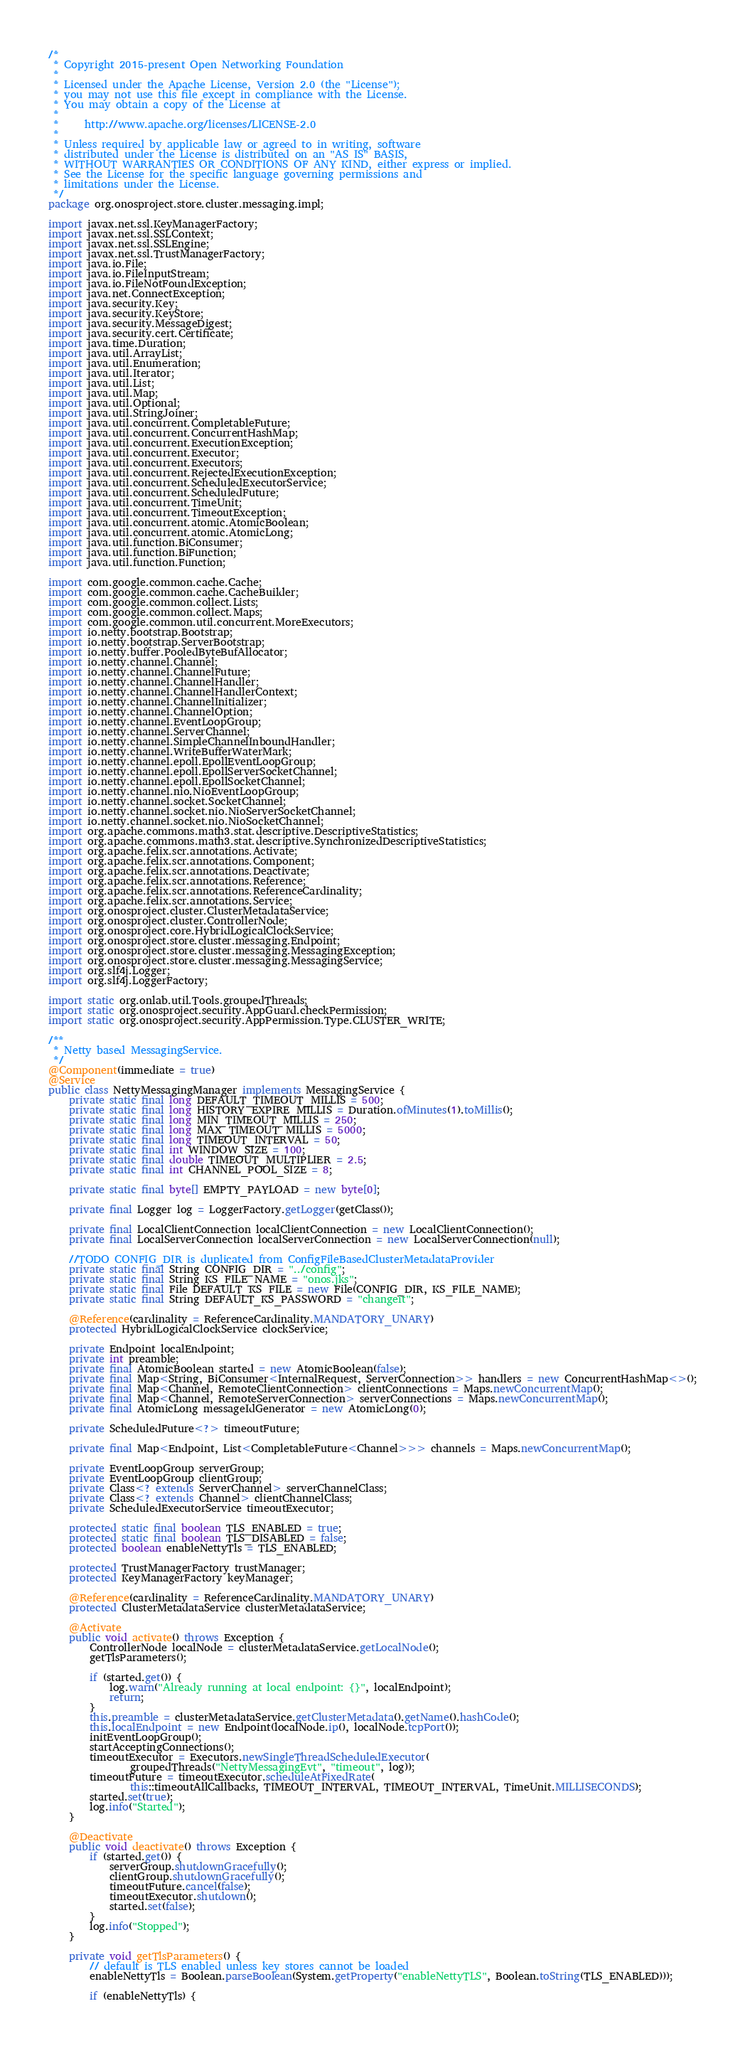<code> <loc_0><loc_0><loc_500><loc_500><_Java_>/*
 * Copyright 2015-present Open Networking Foundation
 *
 * Licensed under the Apache License, Version 2.0 (the "License");
 * you may not use this file except in compliance with the License.
 * You may obtain a copy of the License at
 *
 *     http://www.apache.org/licenses/LICENSE-2.0
 *
 * Unless required by applicable law or agreed to in writing, software
 * distributed under the License is distributed on an "AS IS" BASIS,
 * WITHOUT WARRANTIES OR CONDITIONS OF ANY KIND, either express or implied.
 * See the License for the specific language governing permissions and
 * limitations under the License.
 */
package org.onosproject.store.cluster.messaging.impl;

import javax.net.ssl.KeyManagerFactory;
import javax.net.ssl.SSLContext;
import javax.net.ssl.SSLEngine;
import javax.net.ssl.TrustManagerFactory;
import java.io.File;
import java.io.FileInputStream;
import java.io.FileNotFoundException;
import java.net.ConnectException;
import java.security.Key;
import java.security.KeyStore;
import java.security.MessageDigest;
import java.security.cert.Certificate;
import java.time.Duration;
import java.util.ArrayList;
import java.util.Enumeration;
import java.util.Iterator;
import java.util.List;
import java.util.Map;
import java.util.Optional;
import java.util.StringJoiner;
import java.util.concurrent.CompletableFuture;
import java.util.concurrent.ConcurrentHashMap;
import java.util.concurrent.ExecutionException;
import java.util.concurrent.Executor;
import java.util.concurrent.Executors;
import java.util.concurrent.RejectedExecutionException;
import java.util.concurrent.ScheduledExecutorService;
import java.util.concurrent.ScheduledFuture;
import java.util.concurrent.TimeUnit;
import java.util.concurrent.TimeoutException;
import java.util.concurrent.atomic.AtomicBoolean;
import java.util.concurrent.atomic.AtomicLong;
import java.util.function.BiConsumer;
import java.util.function.BiFunction;
import java.util.function.Function;

import com.google.common.cache.Cache;
import com.google.common.cache.CacheBuilder;
import com.google.common.collect.Lists;
import com.google.common.collect.Maps;
import com.google.common.util.concurrent.MoreExecutors;
import io.netty.bootstrap.Bootstrap;
import io.netty.bootstrap.ServerBootstrap;
import io.netty.buffer.PooledByteBufAllocator;
import io.netty.channel.Channel;
import io.netty.channel.ChannelFuture;
import io.netty.channel.ChannelHandler;
import io.netty.channel.ChannelHandlerContext;
import io.netty.channel.ChannelInitializer;
import io.netty.channel.ChannelOption;
import io.netty.channel.EventLoopGroup;
import io.netty.channel.ServerChannel;
import io.netty.channel.SimpleChannelInboundHandler;
import io.netty.channel.WriteBufferWaterMark;
import io.netty.channel.epoll.EpollEventLoopGroup;
import io.netty.channel.epoll.EpollServerSocketChannel;
import io.netty.channel.epoll.EpollSocketChannel;
import io.netty.channel.nio.NioEventLoopGroup;
import io.netty.channel.socket.SocketChannel;
import io.netty.channel.socket.nio.NioServerSocketChannel;
import io.netty.channel.socket.nio.NioSocketChannel;
import org.apache.commons.math3.stat.descriptive.DescriptiveStatistics;
import org.apache.commons.math3.stat.descriptive.SynchronizedDescriptiveStatistics;
import org.apache.felix.scr.annotations.Activate;
import org.apache.felix.scr.annotations.Component;
import org.apache.felix.scr.annotations.Deactivate;
import org.apache.felix.scr.annotations.Reference;
import org.apache.felix.scr.annotations.ReferenceCardinality;
import org.apache.felix.scr.annotations.Service;
import org.onosproject.cluster.ClusterMetadataService;
import org.onosproject.cluster.ControllerNode;
import org.onosproject.core.HybridLogicalClockService;
import org.onosproject.store.cluster.messaging.Endpoint;
import org.onosproject.store.cluster.messaging.MessagingException;
import org.onosproject.store.cluster.messaging.MessagingService;
import org.slf4j.Logger;
import org.slf4j.LoggerFactory;

import static org.onlab.util.Tools.groupedThreads;
import static org.onosproject.security.AppGuard.checkPermission;
import static org.onosproject.security.AppPermission.Type.CLUSTER_WRITE;

/**
 * Netty based MessagingService.
 */
@Component(immediate = true)
@Service
public class NettyMessagingManager implements MessagingService {
    private static final long DEFAULT_TIMEOUT_MILLIS = 500;
    private static final long HISTORY_EXPIRE_MILLIS = Duration.ofMinutes(1).toMillis();
    private static final long MIN_TIMEOUT_MILLIS = 250;
    private static final long MAX_TIMEOUT_MILLIS = 5000;
    private static final long TIMEOUT_INTERVAL = 50;
    private static final int WINDOW_SIZE = 100;
    private static final double TIMEOUT_MULTIPLIER = 2.5;
    private static final int CHANNEL_POOL_SIZE = 8;

    private static final byte[] EMPTY_PAYLOAD = new byte[0];

    private final Logger log = LoggerFactory.getLogger(getClass());

    private final LocalClientConnection localClientConnection = new LocalClientConnection();
    private final LocalServerConnection localServerConnection = new LocalServerConnection(null);

    //TODO CONFIG_DIR is duplicated from ConfigFileBasedClusterMetadataProvider
    private static final String CONFIG_DIR = "../config";
    private static final String KS_FILE_NAME = "onos.jks";
    private static final File DEFAULT_KS_FILE = new File(CONFIG_DIR, KS_FILE_NAME);
    private static final String DEFAULT_KS_PASSWORD = "changeit";

    @Reference(cardinality = ReferenceCardinality.MANDATORY_UNARY)
    protected HybridLogicalClockService clockService;

    private Endpoint localEndpoint;
    private int preamble;
    private final AtomicBoolean started = new AtomicBoolean(false);
    private final Map<String, BiConsumer<InternalRequest, ServerConnection>> handlers = new ConcurrentHashMap<>();
    private final Map<Channel, RemoteClientConnection> clientConnections = Maps.newConcurrentMap();
    private final Map<Channel, RemoteServerConnection> serverConnections = Maps.newConcurrentMap();
    private final AtomicLong messageIdGenerator = new AtomicLong(0);

    private ScheduledFuture<?> timeoutFuture;

    private final Map<Endpoint, List<CompletableFuture<Channel>>> channels = Maps.newConcurrentMap();

    private EventLoopGroup serverGroup;
    private EventLoopGroup clientGroup;
    private Class<? extends ServerChannel> serverChannelClass;
    private Class<? extends Channel> clientChannelClass;
    private ScheduledExecutorService timeoutExecutor;

    protected static final boolean TLS_ENABLED = true;
    protected static final boolean TLS_DISABLED = false;
    protected boolean enableNettyTls = TLS_ENABLED;

    protected TrustManagerFactory trustManager;
    protected KeyManagerFactory keyManager;

    @Reference(cardinality = ReferenceCardinality.MANDATORY_UNARY)
    protected ClusterMetadataService clusterMetadataService;

    @Activate
    public void activate() throws Exception {
        ControllerNode localNode = clusterMetadataService.getLocalNode();
        getTlsParameters();

        if (started.get()) {
            log.warn("Already running at local endpoint: {}", localEndpoint);
            return;
        }
        this.preamble = clusterMetadataService.getClusterMetadata().getName().hashCode();
        this.localEndpoint = new Endpoint(localNode.ip(), localNode.tcpPort());
        initEventLoopGroup();
        startAcceptingConnections();
        timeoutExecutor = Executors.newSingleThreadScheduledExecutor(
                groupedThreads("NettyMessagingEvt", "timeout", log));
        timeoutFuture = timeoutExecutor.scheduleAtFixedRate(
                this::timeoutAllCallbacks, TIMEOUT_INTERVAL, TIMEOUT_INTERVAL, TimeUnit.MILLISECONDS);
        started.set(true);
        log.info("Started");
    }

    @Deactivate
    public void deactivate() throws Exception {
        if (started.get()) {
            serverGroup.shutdownGracefully();
            clientGroup.shutdownGracefully();
            timeoutFuture.cancel(false);
            timeoutExecutor.shutdown();
            started.set(false);
        }
        log.info("Stopped");
    }

    private void getTlsParameters() {
        // default is TLS enabled unless key stores cannot be loaded
        enableNettyTls = Boolean.parseBoolean(System.getProperty("enableNettyTLS", Boolean.toString(TLS_ENABLED)));

        if (enableNettyTls) {</code> 